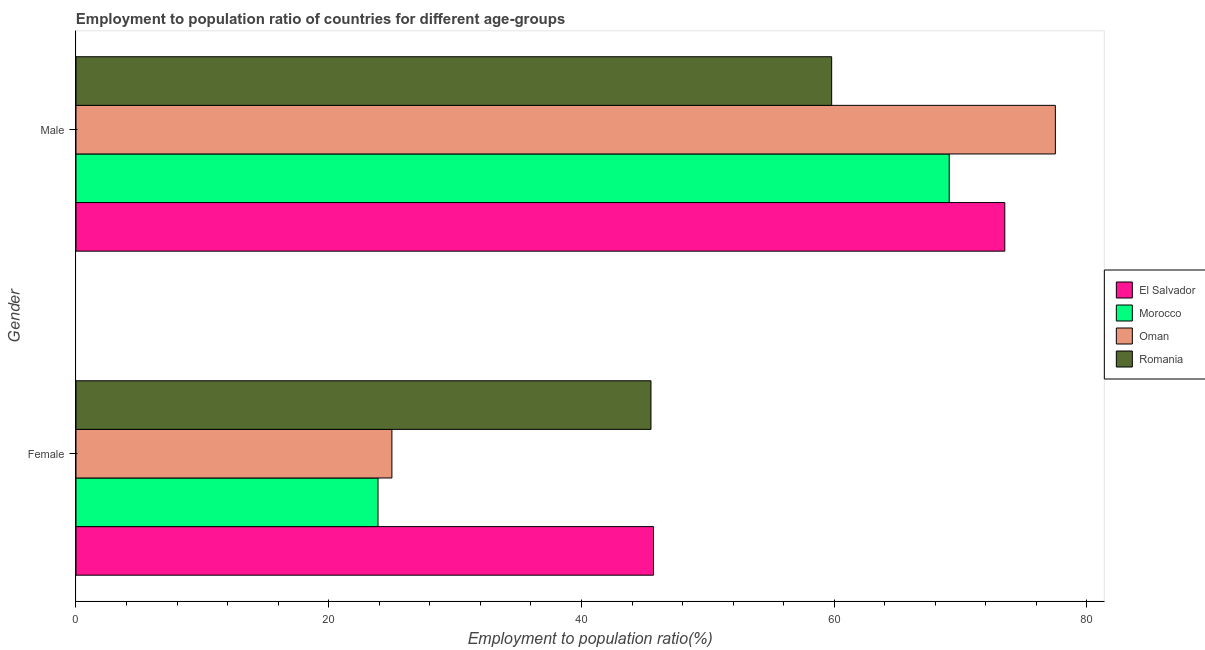How many different coloured bars are there?
Ensure brevity in your answer.  4. How many groups of bars are there?
Provide a succinct answer. 2. Are the number of bars on each tick of the Y-axis equal?
Keep it short and to the point. Yes. How many bars are there on the 2nd tick from the bottom?
Give a very brief answer. 4. What is the employment to population ratio(male) in El Salvador?
Give a very brief answer. 73.5. Across all countries, what is the maximum employment to population ratio(female)?
Your response must be concise. 45.7. Across all countries, what is the minimum employment to population ratio(male)?
Make the answer very short. 59.8. In which country was the employment to population ratio(male) maximum?
Provide a succinct answer. Oman. In which country was the employment to population ratio(male) minimum?
Make the answer very short. Romania. What is the total employment to population ratio(male) in the graph?
Your response must be concise. 279.9. What is the difference between the employment to population ratio(male) in El Salvador and that in Oman?
Provide a short and direct response. -4. What is the difference between the employment to population ratio(male) in Oman and the employment to population ratio(female) in Morocco?
Your answer should be very brief. 53.6. What is the average employment to population ratio(female) per country?
Provide a succinct answer. 35.03. What is the difference between the employment to population ratio(male) and employment to population ratio(female) in Oman?
Your answer should be very brief. 52.5. In how many countries, is the employment to population ratio(male) greater than 76 %?
Provide a succinct answer. 1. What is the ratio of the employment to population ratio(male) in Oman to that in Romania?
Keep it short and to the point. 1.3. In how many countries, is the employment to population ratio(male) greater than the average employment to population ratio(male) taken over all countries?
Ensure brevity in your answer.  2. What does the 1st bar from the top in Male represents?
Ensure brevity in your answer.  Romania. What does the 2nd bar from the bottom in Male represents?
Provide a short and direct response. Morocco. Are all the bars in the graph horizontal?
Give a very brief answer. Yes. Are the values on the major ticks of X-axis written in scientific E-notation?
Offer a very short reply. No. Does the graph contain any zero values?
Offer a very short reply. No. Does the graph contain grids?
Provide a short and direct response. No. Where does the legend appear in the graph?
Give a very brief answer. Center right. How are the legend labels stacked?
Give a very brief answer. Vertical. What is the title of the graph?
Keep it short and to the point. Employment to population ratio of countries for different age-groups. What is the Employment to population ratio(%) of El Salvador in Female?
Offer a terse response. 45.7. What is the Employment to population ratio(%) of Morocco in Female?
Offer a terse response. 23.9. What is the Employment to population ratio(%) of Romania in Female?
Provide a short and direct response. 45.5. What is the Employment to population ratio(%) of El Salvador in Male?
Your answer should be compact. 73.5. What is the Employment to population ratio(%) of Morocco in Male?
Your response must be concise. 69.1. What is the Employment to population ratio(%) of Oman in Male?
Provide a short and direct response. 77.5. What is the Employment to population ratio(%) in Romania in Male?
Make the answer very short. 59.8. Across all Gender, what is the maximum Employment to population ratio(%) in El Salvador?
Keep it short and to the point. 73.5. Across all Gender, what is the maximum Employment to population ratio(%) of Morocco?
Keep it short and to the point. 69.1. Across all Gender, what is the maximum Employment to population ratio(%) of Oman?
Offer a very short reply. 77.5. Across all Gender, what is the maximum Employment to population ratio(%) of Romania?
Provide a short and direct response. 59.8. Across all Gender, what is the minimum Employment to population ratio(%) in El Salvador?
Your answer should be compact. 45.7. Across all Gender, what is the minimum Employment to population ratio(%) of Morocco?
Make the answer very short. 23.9. Across all Gender, what is the minimum Employment to population ratio(%) in Oman?
Offer a very short reply. 25. Across all Gender, what is the minimum Employment to population ratio(%) in Romania?
Keep it short and to the point. 45.5. What is the total Employment to population ratio(%) in El Salvador in the graph?
Your answer should be compact. 119.2. What is the total Employment to population ratio(%) in Morocco in the graph?
Your response must be concise. 93. What is the total Employment to population ratio(%) of Oman in the graph?
Give a very brief answer. 102.5. What is the total Employment to population ratio(%) of Romania in the graph?
Your answer should be compact. 105.3. What is the difference between the Employment to population ratio(%) of El Salvador in Female and that in Male?
Provide a succinct answer. -27.8. What is the difference between the Employment to population ratio(%) in Morocco in Female and that in Male?
Provide a short and direct response. -45.2. What is the difference between the Employment to population ratio(%) of Oman in Female and that in Male?
Give a very brief answer. -52.5. What is the difference between the Employment to population ratio(%) of Romania in Female and that in Male?
Keep it short and to the point. -14.3. What is the difference between the Employment to population ratio(%) in El Salvador in Female and the Employment to population ratio(%) in Morocco in Male?
Offer a very short reply. -23.4. What is the difference between the Employment to population ratio(%) of El Salvador in Female and the Employment to population ratio(%) of Oman in Male?
Give a very brief answer. -31.8. What is the difference between the Employment to population ratio(%) of El Salvador in Female and the Employment to population ratio(%) of Romania in Male?
Keep it short and to the point. -14.1. What is the difference between the Employment to population ratio(%) of Morocco in Female and the Employment to population ratio(%) of Oman in Male?
Offer a very short reply. -53.6. What is the difference between the Employment to population ratio(%) of Morocco in Female and the Employment to population ratio(%) of Romania in Male?
Your response must be concise. -35.9. What is the difference between the Employment to population ratio(%) of Oman in Female and the Employment to population ratio(%) of Romania in Male?
Your answer should be compact. -34.8. What is the average Employment to population ratio(%) of El Salvador per Gender?
Offer a very short reply. 59.6. What is the average Employment to population ratio(%) of Morocco per Gender?
Provide a short and direct response. 46.5. What is the average Employment to population ratio(%) in Oman per Gender?
Offer a terse response. 51.25. What is the average Employment to population ratio(%) of Romania per Gender?
Provide a succinct answer. 52.65. What is the difference between the Employment to population ratio(%) in El Salvador and Employment to population ratio(%) in Morocco in Female?
Your answer should be compact. 21.8. What is the difference between the Employment to population ratio(%) in El Salvador and Employment to population ratio(%) in Oman in Female?
Offer a terse response. 20.7. What is the difference between the Employment to population ratio(%) in Morocco and Employment to population ratio(%) in Oman in Female?
Offer a terse response. -1.1. What is the difference between the Employment to population ratio(%) in Morocco and Employment to population ratio(%) in Romania in Female?
Provide a short and direct response. -21.6. What is the difference between the Employment to population ratio(%) in Oman and Employment to population ratio(%) in Romania in Female?
Ensure brevity in your answer.  -20.5. What is the difference between the Employment to population ratio(%) in El Salvador and Employment to population ratio(%) in Oman in Male?
Your answer should be compact. -4. What is the difference between the Employment to population ratio(%) of Morocco and Employment to population ratio(%) of Romania in Male?
Offer a terse response. 9.3. What is the difference between the Employment to population ratio(%) in Oman and Employment to population ratio(%) in Romania in Male?
Ensure brevity in your answer.  17.7. What is the ratio of the Employment to population ratio(%) in El Salvador in Female to that in Male?
Your answer should be compact. 0.62. What is the ratio of the Employment to population ratio(%) of Morocco in Female to that in Male?
Your response must be concise. 0.35. What is the ratio of the Employment to population ratio(%) in Oman in Female to that in Male?
Offer a terse response. 0.32. What is the ratio of the Employment to population ratio(%) of Romania in Female to that in Male?
Give a very brief answer. 0.76. What is the difference between the highest and the second highest Employment to population ratio(%) in El Salvador?
Your response must be concise. 27.8. What is the difference between the highest and the second highest Employment to population ratio(%) in Morocco?
Ensure brevity in your answer.  45.2. What is the difference between the highest and the second highest Employment to population ratio(%) of Oman?
Make the answer very short. 52.5. What is the difference between the highest and the lowest Employment to population ratio(%) in El Salvador?
Offer a terse response. 27.8. What is the difference between the highest and the lowest Employment to population ratio(%) in Morocco?
Ensure brevity in your answer.  45.2. What is the difference between the highest and the lowest Employment to population ratio(%) of Oman?
Your answer should be compact. 52.5. What is the difference between the highest and the lowest Employment to population ratio(%) of Romania?
Your response must be concise. 14.3. 